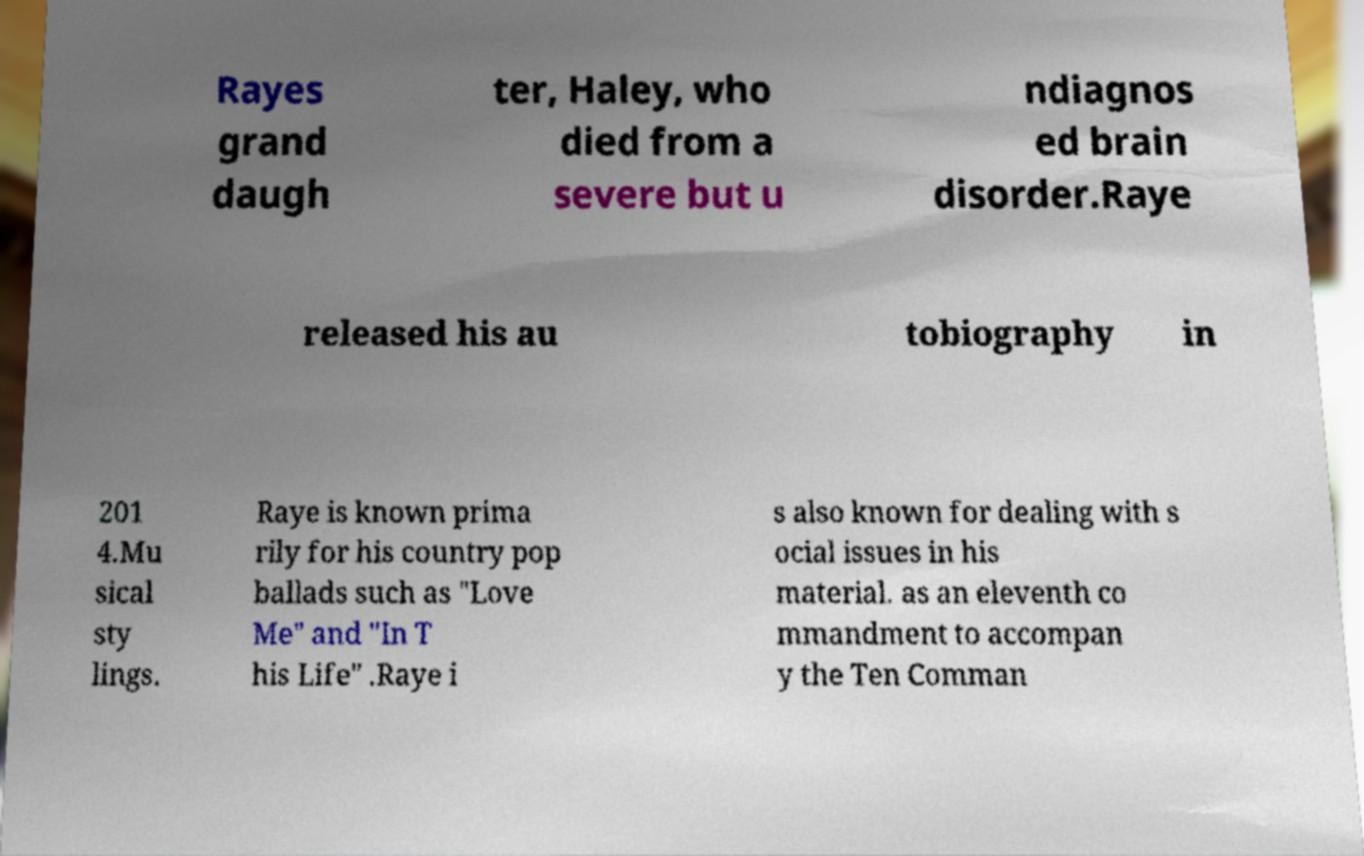Can you accurately transcribe the text from the provided image for me? Rayes grand daugh ter, Haley, who died from a severe but u ndiagnos ed brain disorder.Raye released his au tobiography in 201 4.Mu sical sty lings. Raye is known prima rily for his country pop ballads such as "Love Me" and "In T his Life" .Raye i s also known for dealing with s ocial issues in his material. as an eleventh co mmandment to accompan y the Ten Comman 